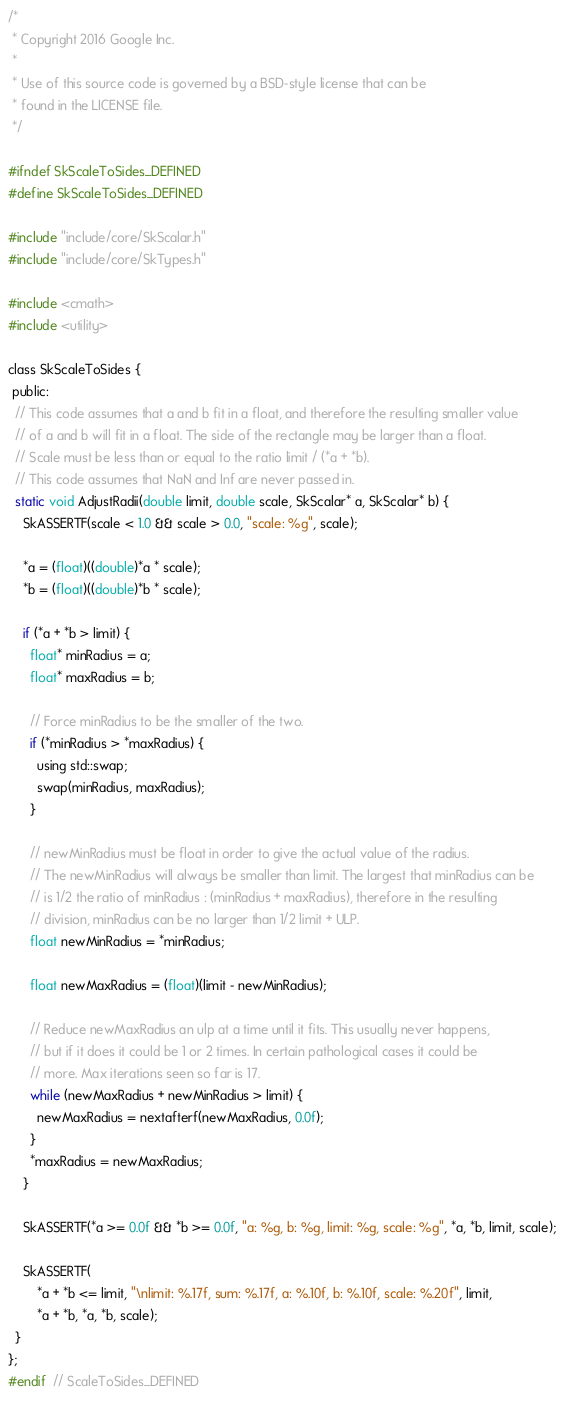<code> <loc_0><loc_0><loc_500><loc_500><_C_>/*
 * Copyright 2016 Google Inc.
 *
 * Use of this source code is governed by a BSD-style license that can be
 * found in the LICENSE file.
 */

#ifndef SkScaleToSides_DEFINED
#define SkScaleToSides_DEFINED

#include "include/core/SkScalar.h"
#include "include/core/SkTypes.h"

#include <cmath>
#include <utility>

class SkScaleToSides {
 public:
  // This code assumes that a and b fit in a float, and therefore the resulting smaller value
  // of a and b will fit in a float. The side of the rectangle may be larger than a float.
  // Scale must be less than or equal to the ratio limit / (*a + *b).
  // This code assumes that NaN and Inf are never passed in.
  static void AdjustRadii(double limit, double scale, SkScalar* a, SkScalar* b) {
    SkASSERTF(scale < 1.0 && scale > 0.0, "scale: %g", scale);

    *a = (float)((double)*a * scale);
    *b = (float)((double)*b * scale);

    if (*a + *b > limit) {
      float* minRadius = a;
      float* maxRadius = b;

      // Force minRadius to be the smaller of the two.
      if (*minRadius > *maxRadius) {
        using std::swap;
        swap(minRadius, maxRadius);
      }

      // newMinRadius must be float in order to give the actual value of the radius.
      // The newMinRadius will always be smaller than limit. The largest that minRadius can be
      // is 1/2 the ratio of minRadius : (minRadius + maxRadius), therefore in the resulting
      // division, minRadius can be no larger than 1/2 limit + ULP.
      float newMinRadius = *minRadius;

      float newMaxRadius = (float)(limit - newMinRadius);

      // Reduce newMaxRadius an ulp at a time until it fits. This usually never happens,
      // but if it does it could be 1 or 2 times. In certain pathological cases it could be
      // more. Max iterations seen so far is 17.
      while (newMaxRadius + newMinRadius > limit) {
        newMaxRadius = nextafterf(newMaxRadius, 0.0f);
      }
      *maxRadius = newMaxRadius;
    }

    SkASSERTF(*a >= 0.0f && *b >= 0.0f, "a: %g, b: %g, limit: %g, scale: %g", *a, *b, limit, scale);

    SkASSERTF(
        *a + *b <= limit, "\nlimit: %.17f, sum: %.17f, a: %.10f, b: %.10f, scale: %.20f", limit,
        *a + *b, *a, *b, scale);
  }
};
#endif  // ScaleToSides_DEFINED
</code> 